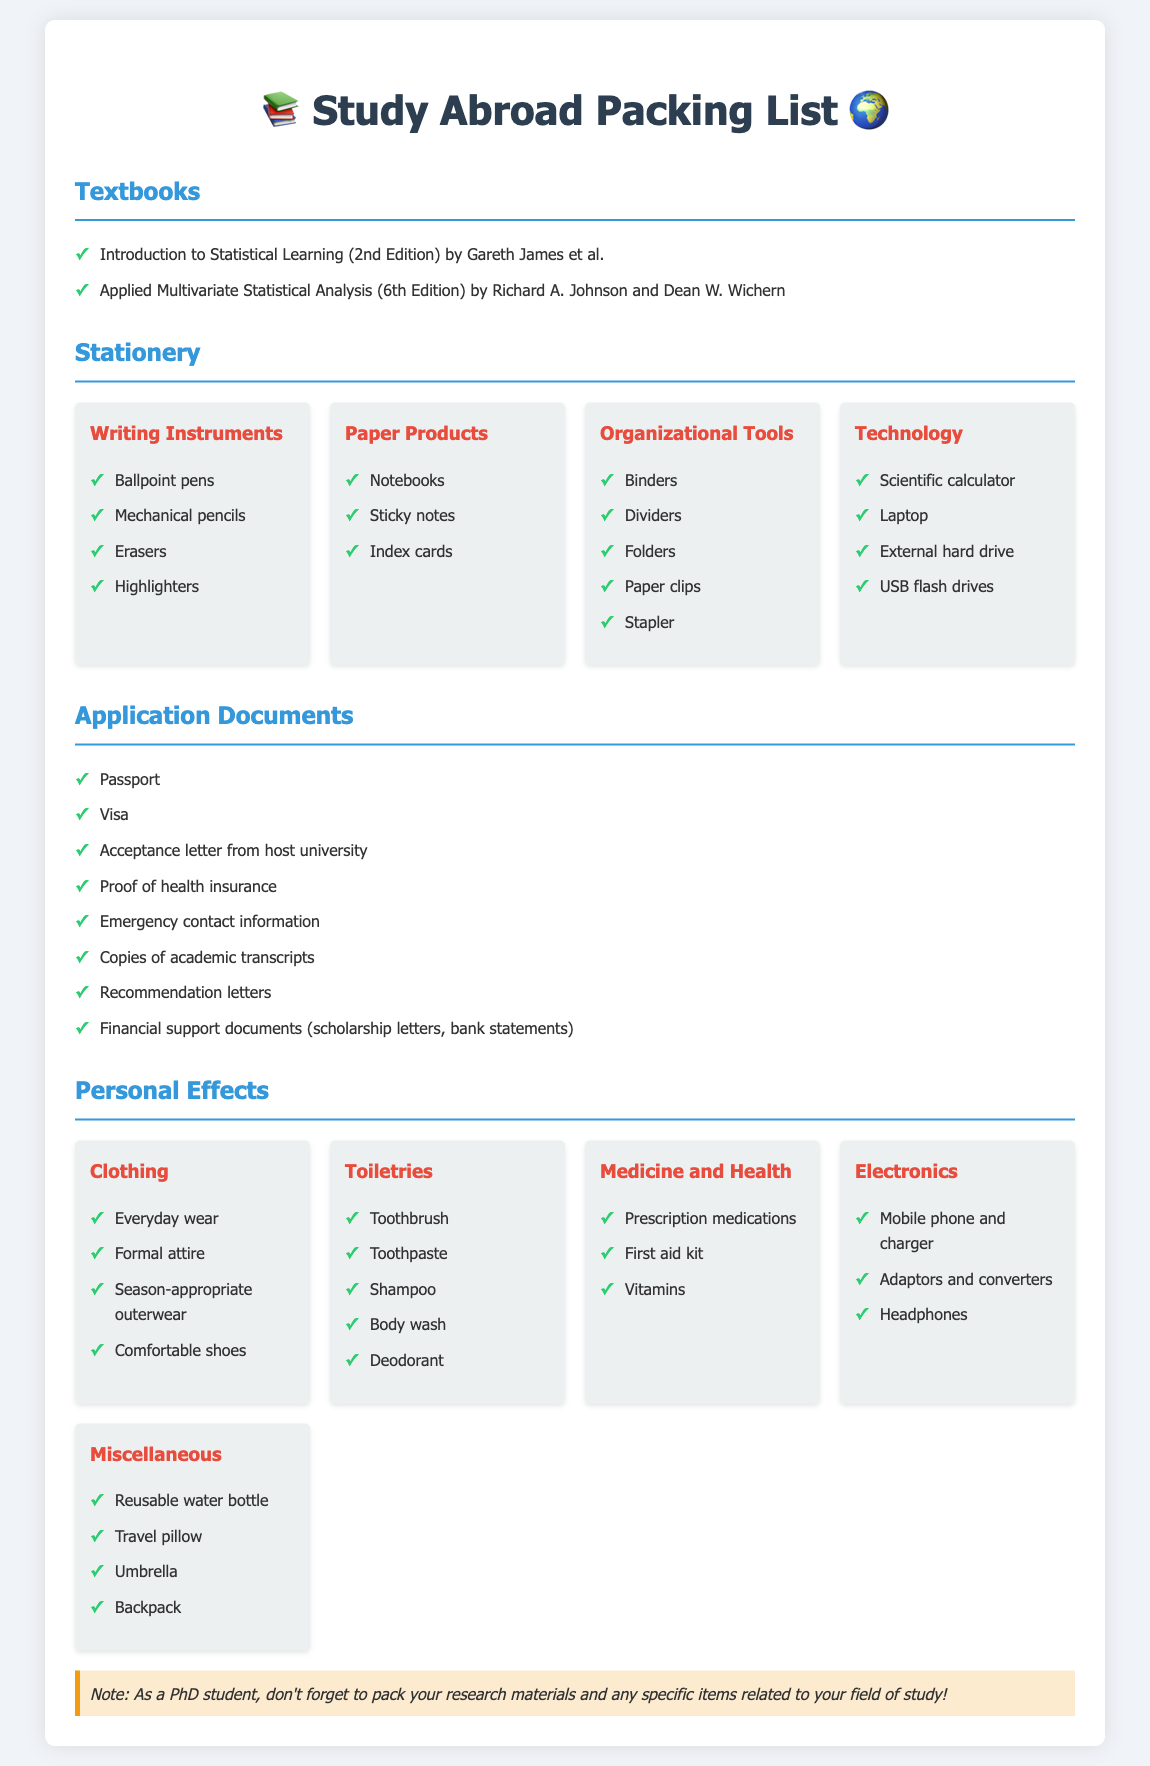What are the titles of the two textbooks listed? The document includes two textbooks under the "Textbooks" section: "Introduction to Statistical Learning (2nd Edition)" and "Applied Multivariate Statistical Analysis (6th Edition)."
Answer: Introduction to Statistical Learning (2nd Edition), Applied Multivariate Statistical Analysis (6th Edition) How many writing instruments are mentioned? The "Writing Instruments" section lists four items: ballpoint pens, mechanical pencils, erasers, and highlighters.
Answer: 4 What personal effects category includes clothing? The "Personal Effects" section has a category titled "Clothing" that details items related to clothing you should pack.
Answer: Clothing What type of documents are required for the application process? The "Application Documents" section outlines several necessary documents such as passport, visa, acceptance letter, etc.
Answer: Passport, Visa, Acceptance letter, Proof of health insurance, Emergency contact information, Copies of academic transcripts, Recommendation letters, Financial support documents Which electronic devices are suggested to pack? The "Electronics" category under "Personal Effects" suggests packing items like a mobile phone, charger, adaptors, and headphones.
Answer: Mobile phone and charger, Adaptors and converters, Headphones 